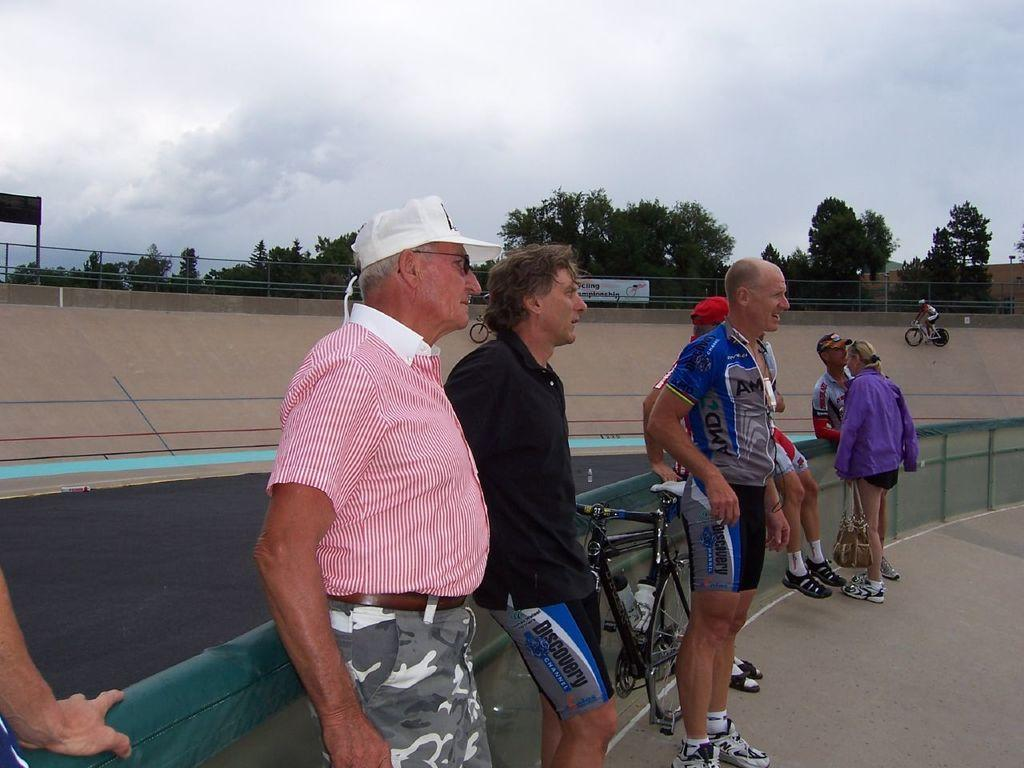What can be seen in the background of the image? There is a sky in the image. What type of vegetation is present in the image? There are trees in the image. What separates the trees from the ground in the image? There is a fence in the image. What is the surface on which the people and bicycle are standing? There is ground visible in the image. How many people are present in the image? There are people standing in the image. What mode of transportation can be seen in the image? There is a bicycle in the image. Can you tell me how many babies are swimming in the ocean in the image? There is no ocean or babies present in the image; it features a sky, trees, a fence, ground, people, and a bicycle. 